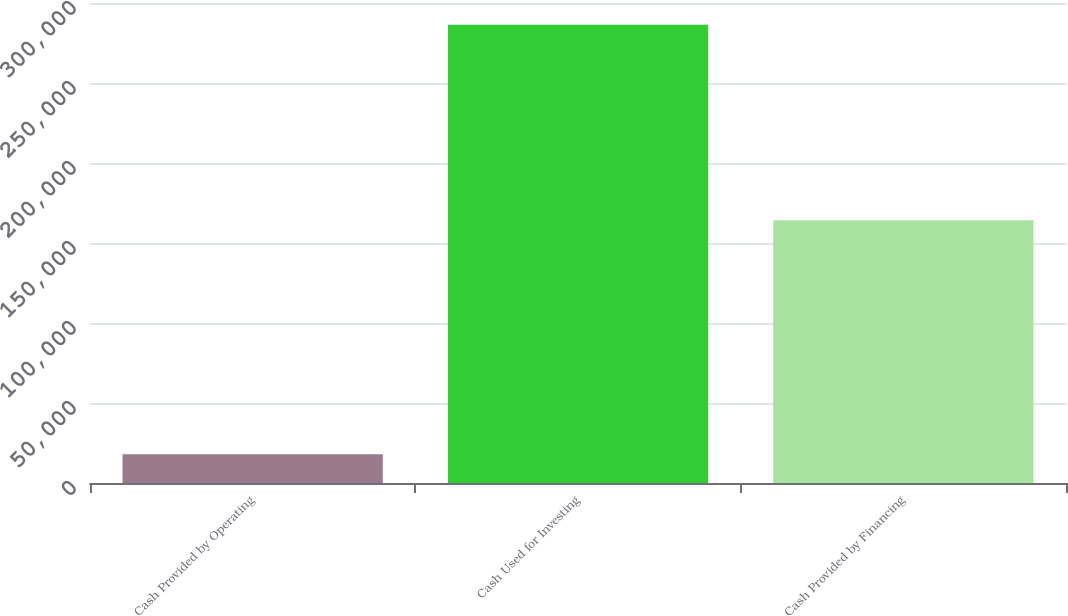<chart> <loc_0><loc_0><loc_500><loc_500><bar_chart><fcel>Cash Provided by Operating<fcel>Cash Used for Investing<fcel>Cash Provided by Financing<nl><fcel>17977<fcel>286339<fcel>164218<nl></chart> 